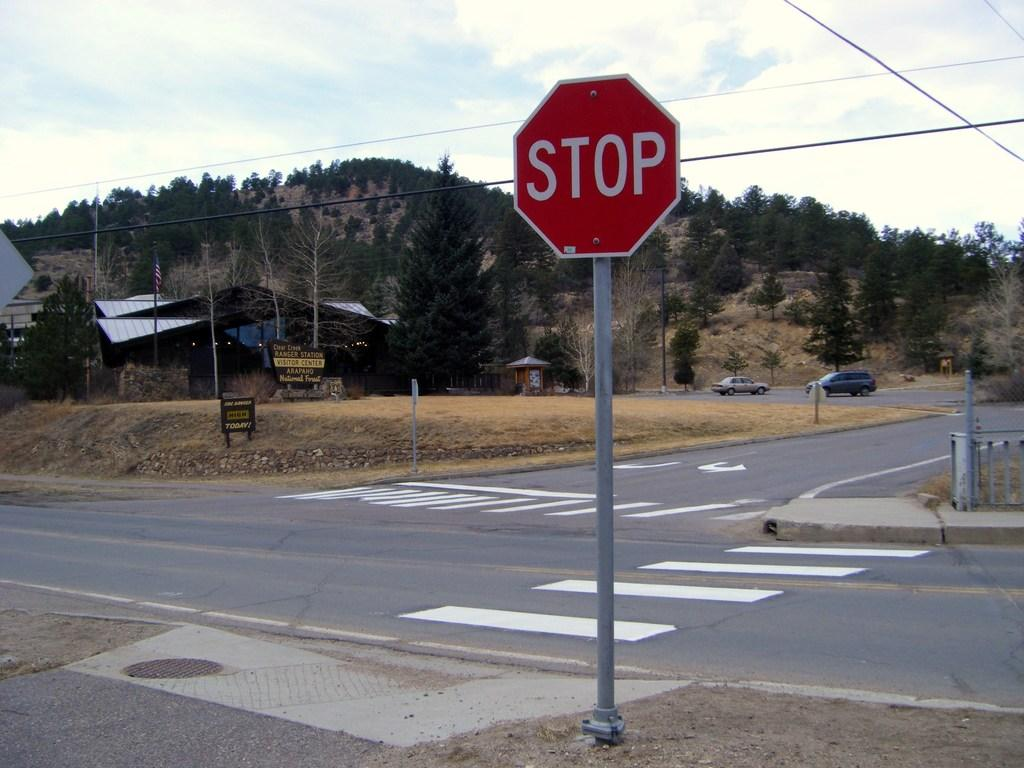<image>
Create a compact narrative representing the image presented. the word stop is on the red and white sign 